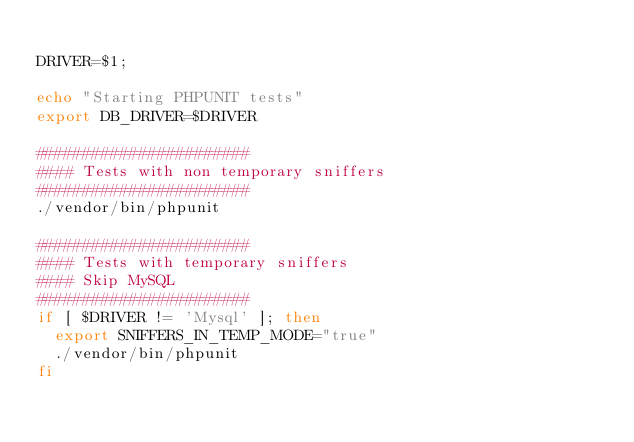Convert code to text. <code><loc_0><loc_0><loc_500><loc_500><_Bash_>
DRIVER=$1;

echo "Starting PHPUNIT tests"
export DB_DRIVER=$DRIVER

#######################
#### Tests with non temporary sniffers
#######################
./vendor/bin/phpunit

#######################
#### Tests with temporary sniffers
#### Skip MySQL
#######################
if [ $DRIVER != 'Mysql' ]; then
  export SNIFFERS_IN_TEMP_MODE="true"
  ./vendor/bin/phpunit
fi
</code> 